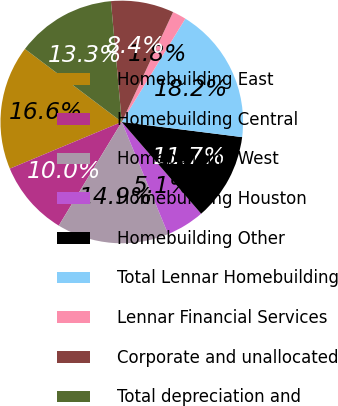<chart> <loc_0><loc_0><loc_500><loc_500><pie_chart><fcel>Homebuilding East<fcel>Homebuilding Central<fcel>Homebuilding West<fcel>Homebuilding Houston<fcel>Homebuilding Other<fcel>Total Lennar Homebuilding<fcel>Lennar Financial Services<fcel>Corporate and unallocated<fcel>Total depreciation and<nl><fcel>16.57%<fcel>10.02%<fcel>14.93%<fcel>5.11%<fcel>11.66%<fcel>18.21%<fcel>1.83%<fcel>8.38%<fcel>13.29%<nl></chart> 